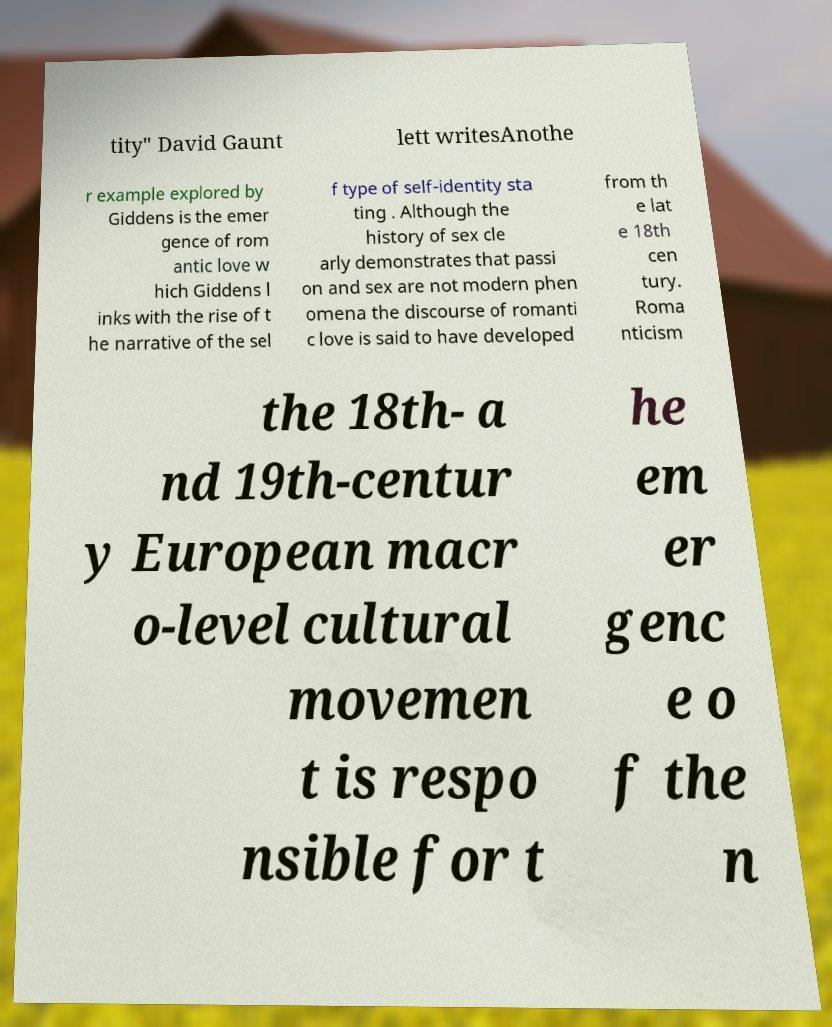Can you accurately transcribe the text from the provided image for me? tity" David Gaunt lett writesAnothe r example explored by Giddens is the emer gence of rom antic love w hich Giddens l inks with the rise of t he narrative of the sel f type of self-identity sta ting . Although the history of sex cle arly demonstrates that passi on and sex are not modern phen omena the discourse of romanti c love is said to have developed from th e lat e 18th cen tury. Roma nticism the 18th- a nd 19th-centur y European macr o-level cultural movemen t is respo nsible for t he em er genc e o f the n 